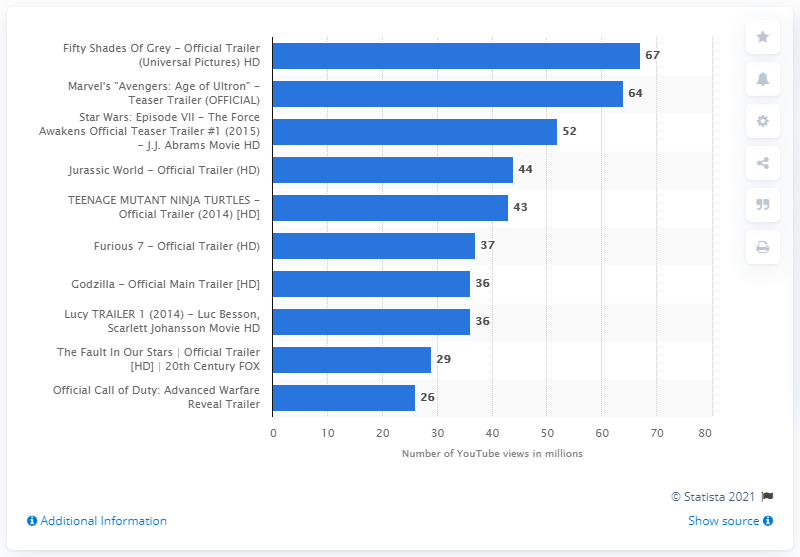Identify some key points in this picture. The Call of Duty: Advanced Warfare Reveal trailer received 26 views. 